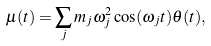<formula> <loc_0><loc_0><loc_500><loc_500>\mu ( t ) = \sum _ { j } m _ { j } \omega _ { j } ^ { 2 } \cos ( \omega _ { j } t ) \theta ( t ) ,</formula> 